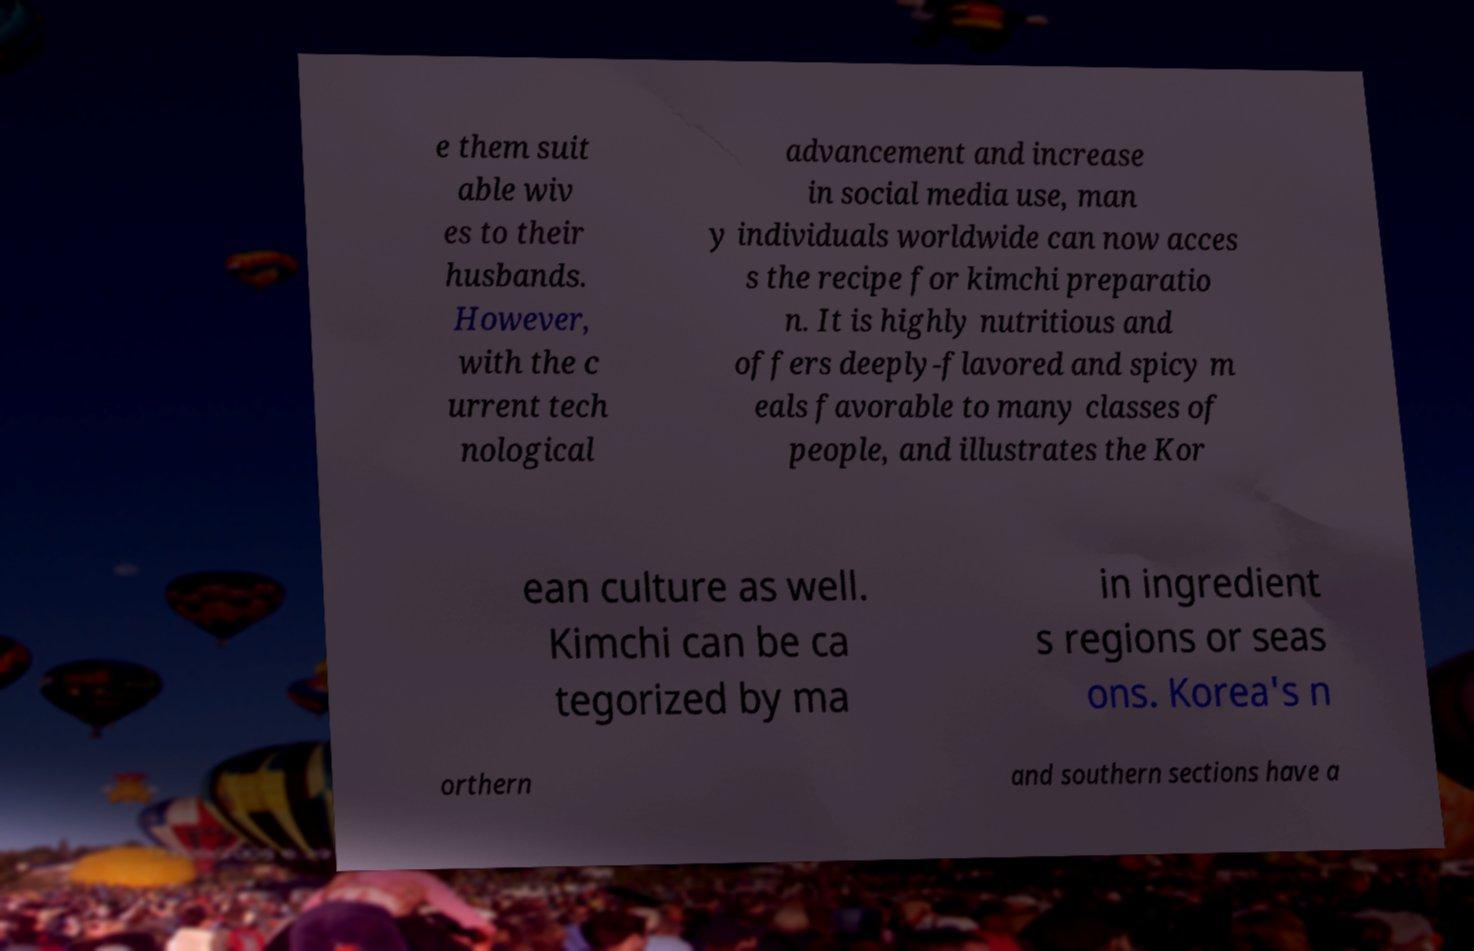Could you extract and type out the text from this image? e them suit able wiv es to their husbands. However, with the c urrent tech nological advancement and increase in social media use, man y individuals worldwide can now acces s the recipe for kimchi preparatio n. It is highly nutritious and offers deeply-flavored and spicy m eals favorable to many classes of people, and illustrates the Kor ean culture as well. Kimchi can be ca tegorized by ma in ingredient s regions or seas ons. Korea's n orthern and southern sections have a 